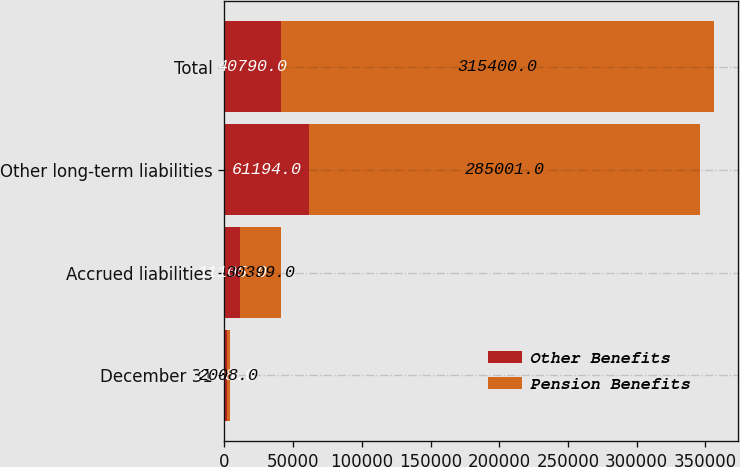Convert chart to OTSL. <chart><loc_0><loc_0><loc_500><loc_500><stacked_bar_chart><ecel><fcel>December 31<fcel>Accrued liabilities<fcel>Other long-term liabilities<fcel>Total<nl><fcel>Other Benefits<fcel>2008<fcel>11105<fcel>61194<fcel>40790<nl><fcel>Pension Benefits<fcel>2008<fcel>30399<fcel>285001<fcel>315400<nl></chart> 